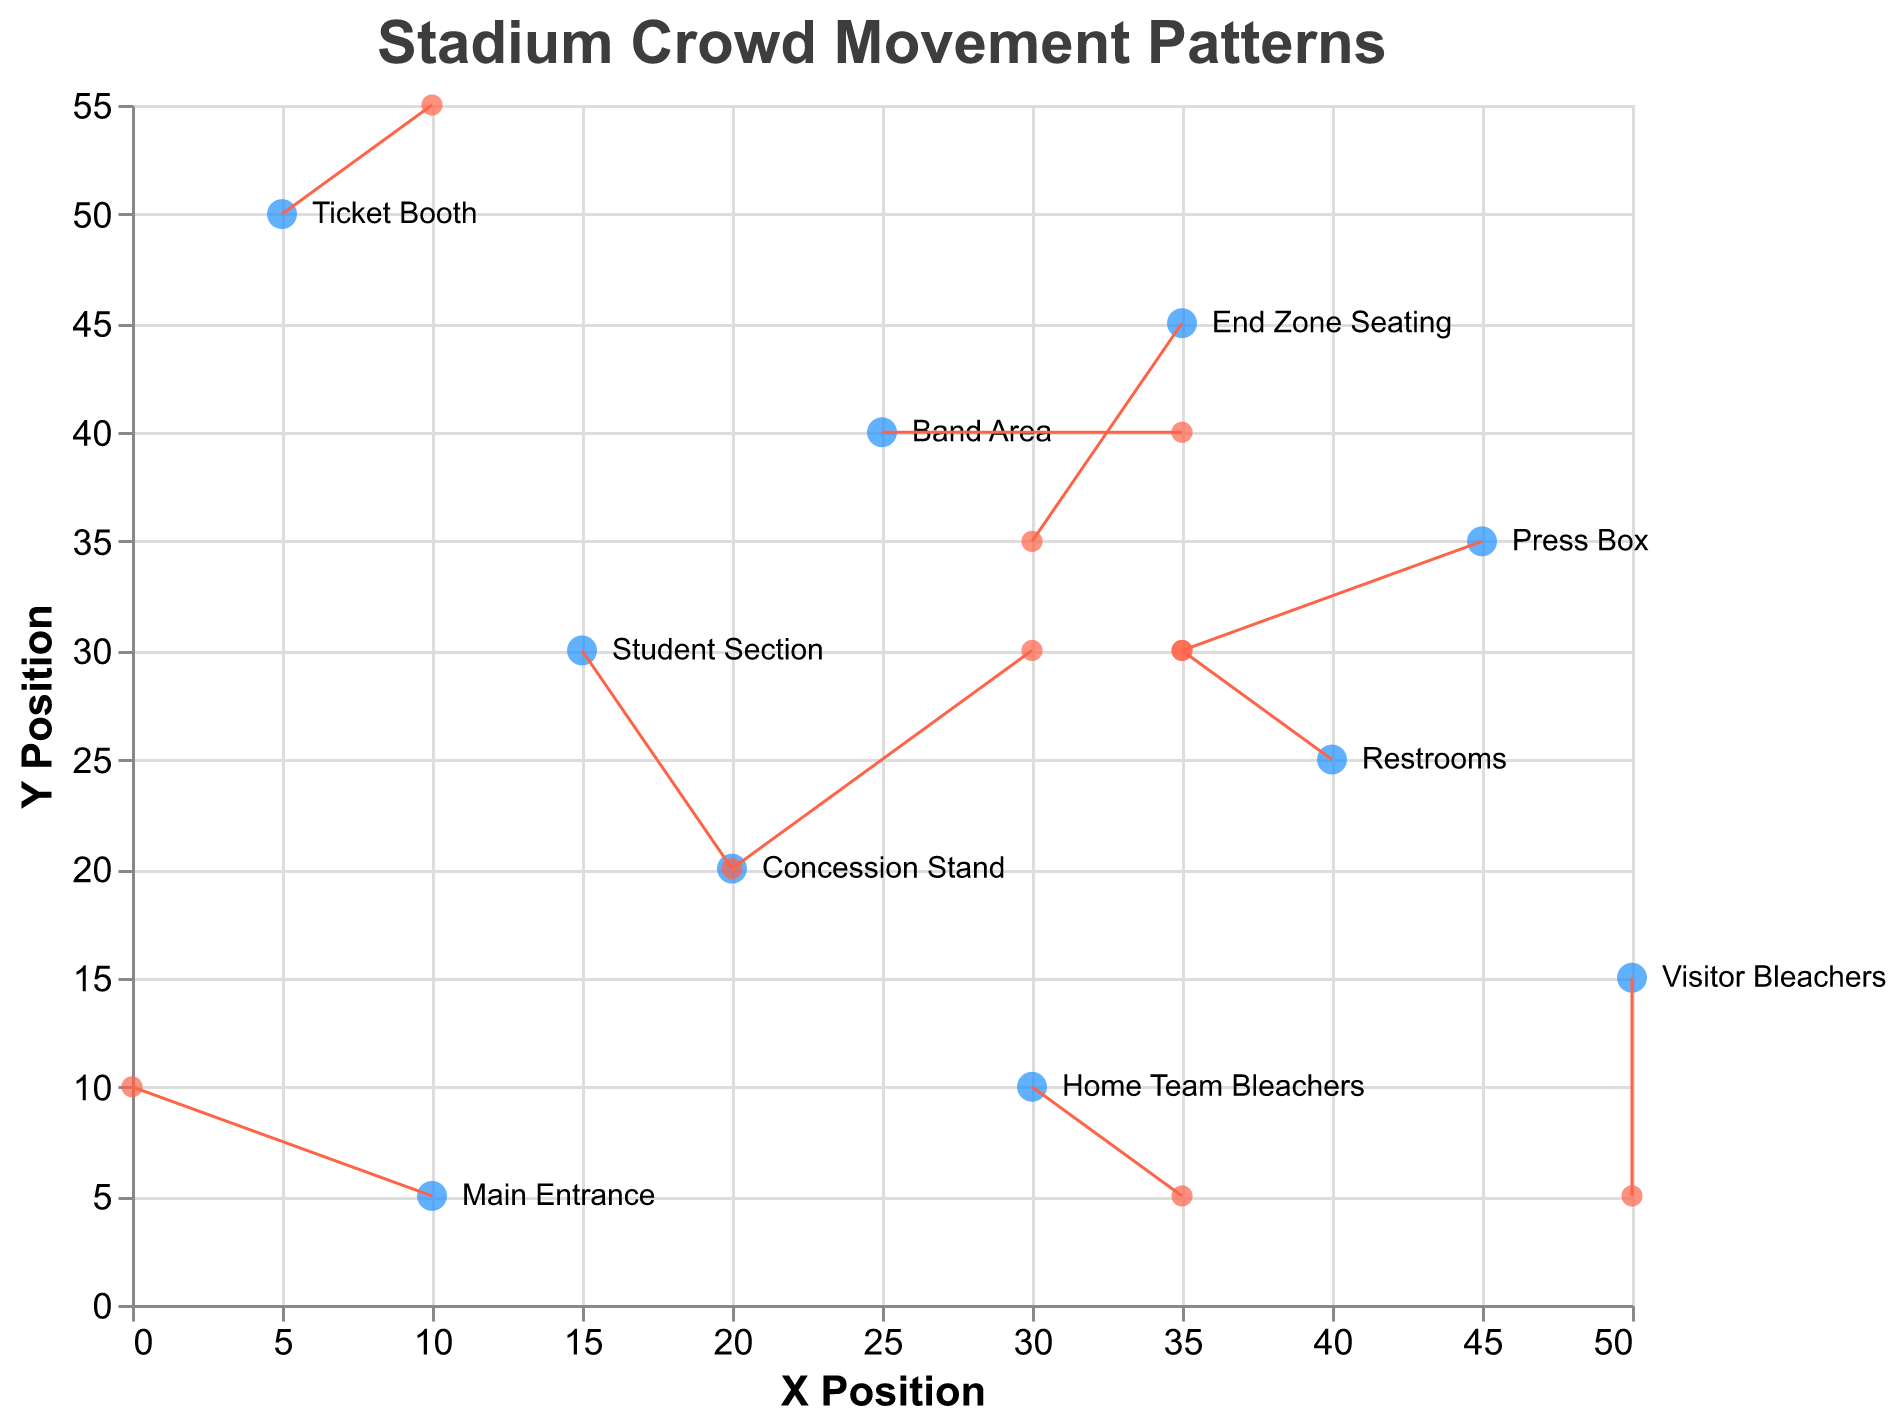What is the highest y position on the plot? The point with the highest y position is the "Ticket Booth" at y = 50.
Answer: Ticket Booth How many data points have an upward (positive) y-direction movement? From the plot, "Main Entrance", "Restrooms", and "Ticket Booth" have upward (positive) y-direction movements. This makes a total of three data points.
Answer: 3 Which two points have the largest movement vector? To determine the vector magnitudes, calculate the Euclidean distance for each point. "Concession Stand" has movement vectors (2, 2) with magnitude √(2^2 + 2^2) = √8 ≈ 2.83,  and "Student Section" has vectors (1, -2) with magnitude √(1^2 + (-2)^2) = √5 ≈ 2.24. The vector with the largest magnitude is "Concession Stand".
Answer: Concession Stand Which point is moving leftward the most? "Press Box" has a movement vector of (-2, -1), indicating the largest leftward (negative x-direction movement).
Answer: Press Box Which point moves westward and northward at the same time? The point moving westward (negative x-direction) and northward (positive y-direction) is the "Restrooms" with movement vector (-1, 1).
Answer: Restrooms Is the movement from the "Home Team Bleachers" more vertical or horizontal? The "Home Team Bleachers" corresponds with a movement vector of (1, -1). The horizontal and vertical components are equal (1 = -1), indicating that the movement is equal in both directions.
Answer: Equal How much total movement in the x-direction is there? Sum up the x-direction movements: -2 (Main Entrance) + 1 (Home Team Bleachers) + 0 (Visitor Bleachers) + 2 (Concession Stand) + -1 (Restrooms) + 1 (Student Section) + -2 (Press Box) + 2 (Band Area) + -1 (End Zone Seating) + 1 (Ticket Booth) = 1.
Answer: 1 Which data point has no movement in either direction? The "Visitor Bleachers" has a movement vector of (0, -2), indicating no movement in the x-direction, but it has downward vertical movement, indicating none have both vectors as zero.
Answer: None How many data points are labeled in the plot? Count all the unique labels appearing next to the points on the plot. There are ten unique labels.
Answer: 10 Which point has the largest downward (negative y-direction) movement? Look for the point with the most negative y-component. The "Visitor Bleachers" has a downward movement vector of (0, -2), which is the largest negative y-direction movement in the plot.
Answer: Visitor Bleachers 